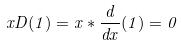Convert formula to latex. <formula><loc_0><loc_0><loc_500><loc_500>x D ( 1 ) = x * \frac { d } { d x } ( 1 ) = 0</formula> 